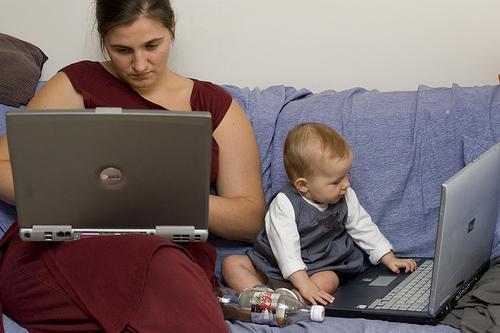How many people are present?
Give a very brief answer. 2. How many adults are there?
Give a very brief answer. 1. How many computers are there?
Give a very brief answer. 2. How many of the people are adults?
Give a very brief answer. 1. How many laptops are shown?
Give a very brief answer. 2. 